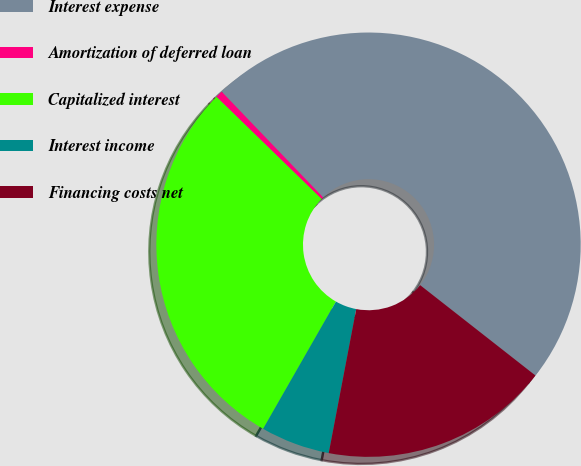<chart> <loc_0><loc_0><loc_500><loc_500><pie_chart><fcel>Interest expense<fcel>Amortization of deferred loan<fcel>Capitalized interest<fcel>Interest income<fcel>Financing costs net<nl><fcel>47.75%<fcel>0.55%<fcel>29.0%<fcel>5.27%<fcel>17.42%<nl></chart> 